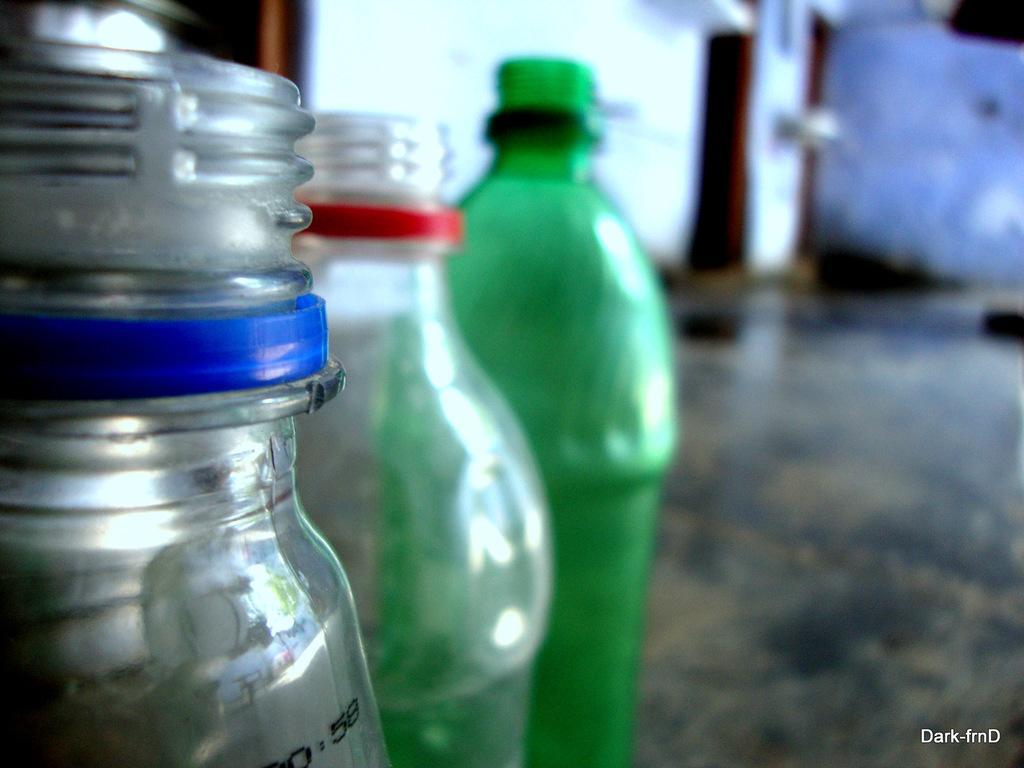How would you summarize this image in a sentence or two? In the image we can see they were three bottles. And coming to background there is a wall. 